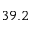<formula> <loc_0><loc_0><loc_500><loc_500>3 9 . 2</formula> 